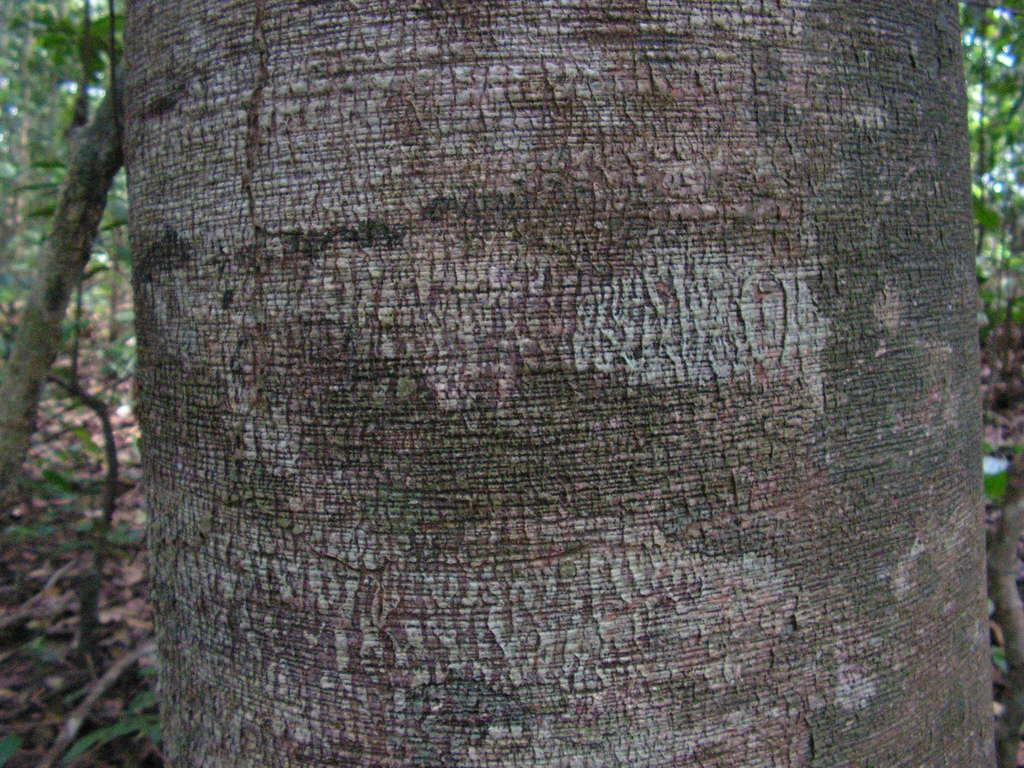What is the main object in the foreground of the image? There is a trunk in the foreground of the image. What can be seen in the background of the image? There are many trees and plants on the ground in the background of the image. What is the purpose of the son in the image? There is no son present in the image, so it is not possible to determine the purpose of a son. 